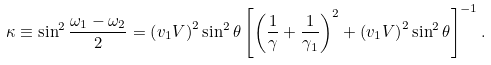Convert formula to latex. <formula><loc_0><loc_0><loc_500><loc_500>\kappa \equiv \sin ^ { 2 } \frac { \omega _ { 1 } - \omega _ { 2 } } { 2 } = \left ( v _ { 1 } V \right ) ^ { 2 } \sin ^ { 2 } \theta \left [ \left ( \frac { 1 } { \gamma } + \frac { 1 } { \gamma _ { 1 } } \right ) ^ { 2 } + \left ( v _ { 1 } V \right ) ^ { 2 } \sin ^ { 2 } \theta \right ] ^ { - 1 } .</formula> 